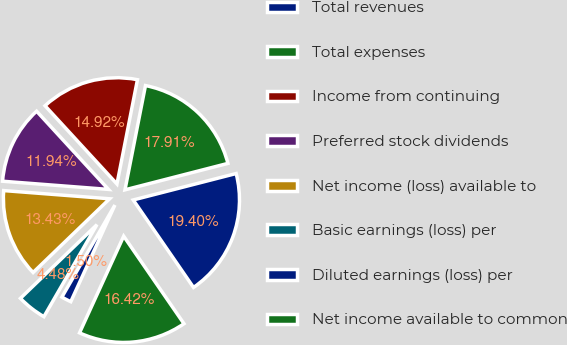Convert chart to OTSL. <chart><loc_0><loc_0><loc_500><loc_500><pie_chart><fcel>Total revenues<fcel>Total expenses<fcel>Income from continuing<fcel>Preferred stock dividends<fcel>Net income (loss) available to<fcel>Basic earnings (loss) per<fcel>Diluted earnings (loss) per<fcel>Net income available to common<nl><fcel>19.4%<fcel>17.91%<fcel>14.92%<fcel>11.94%<fcel>13.43%<fcel>4.48%<fcel>1.5%<fcel>16.42%<nl></chart> 